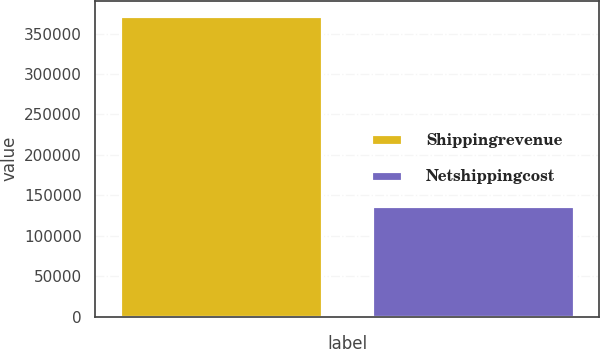Convert chart. <chart><loc_0><loc_0><loc_500><loc_500><bar_chart><fcel>Shippingrevenue<fcel>Netshippingcost<nl><fcel>372000<fcel>136468<nl></chart> 